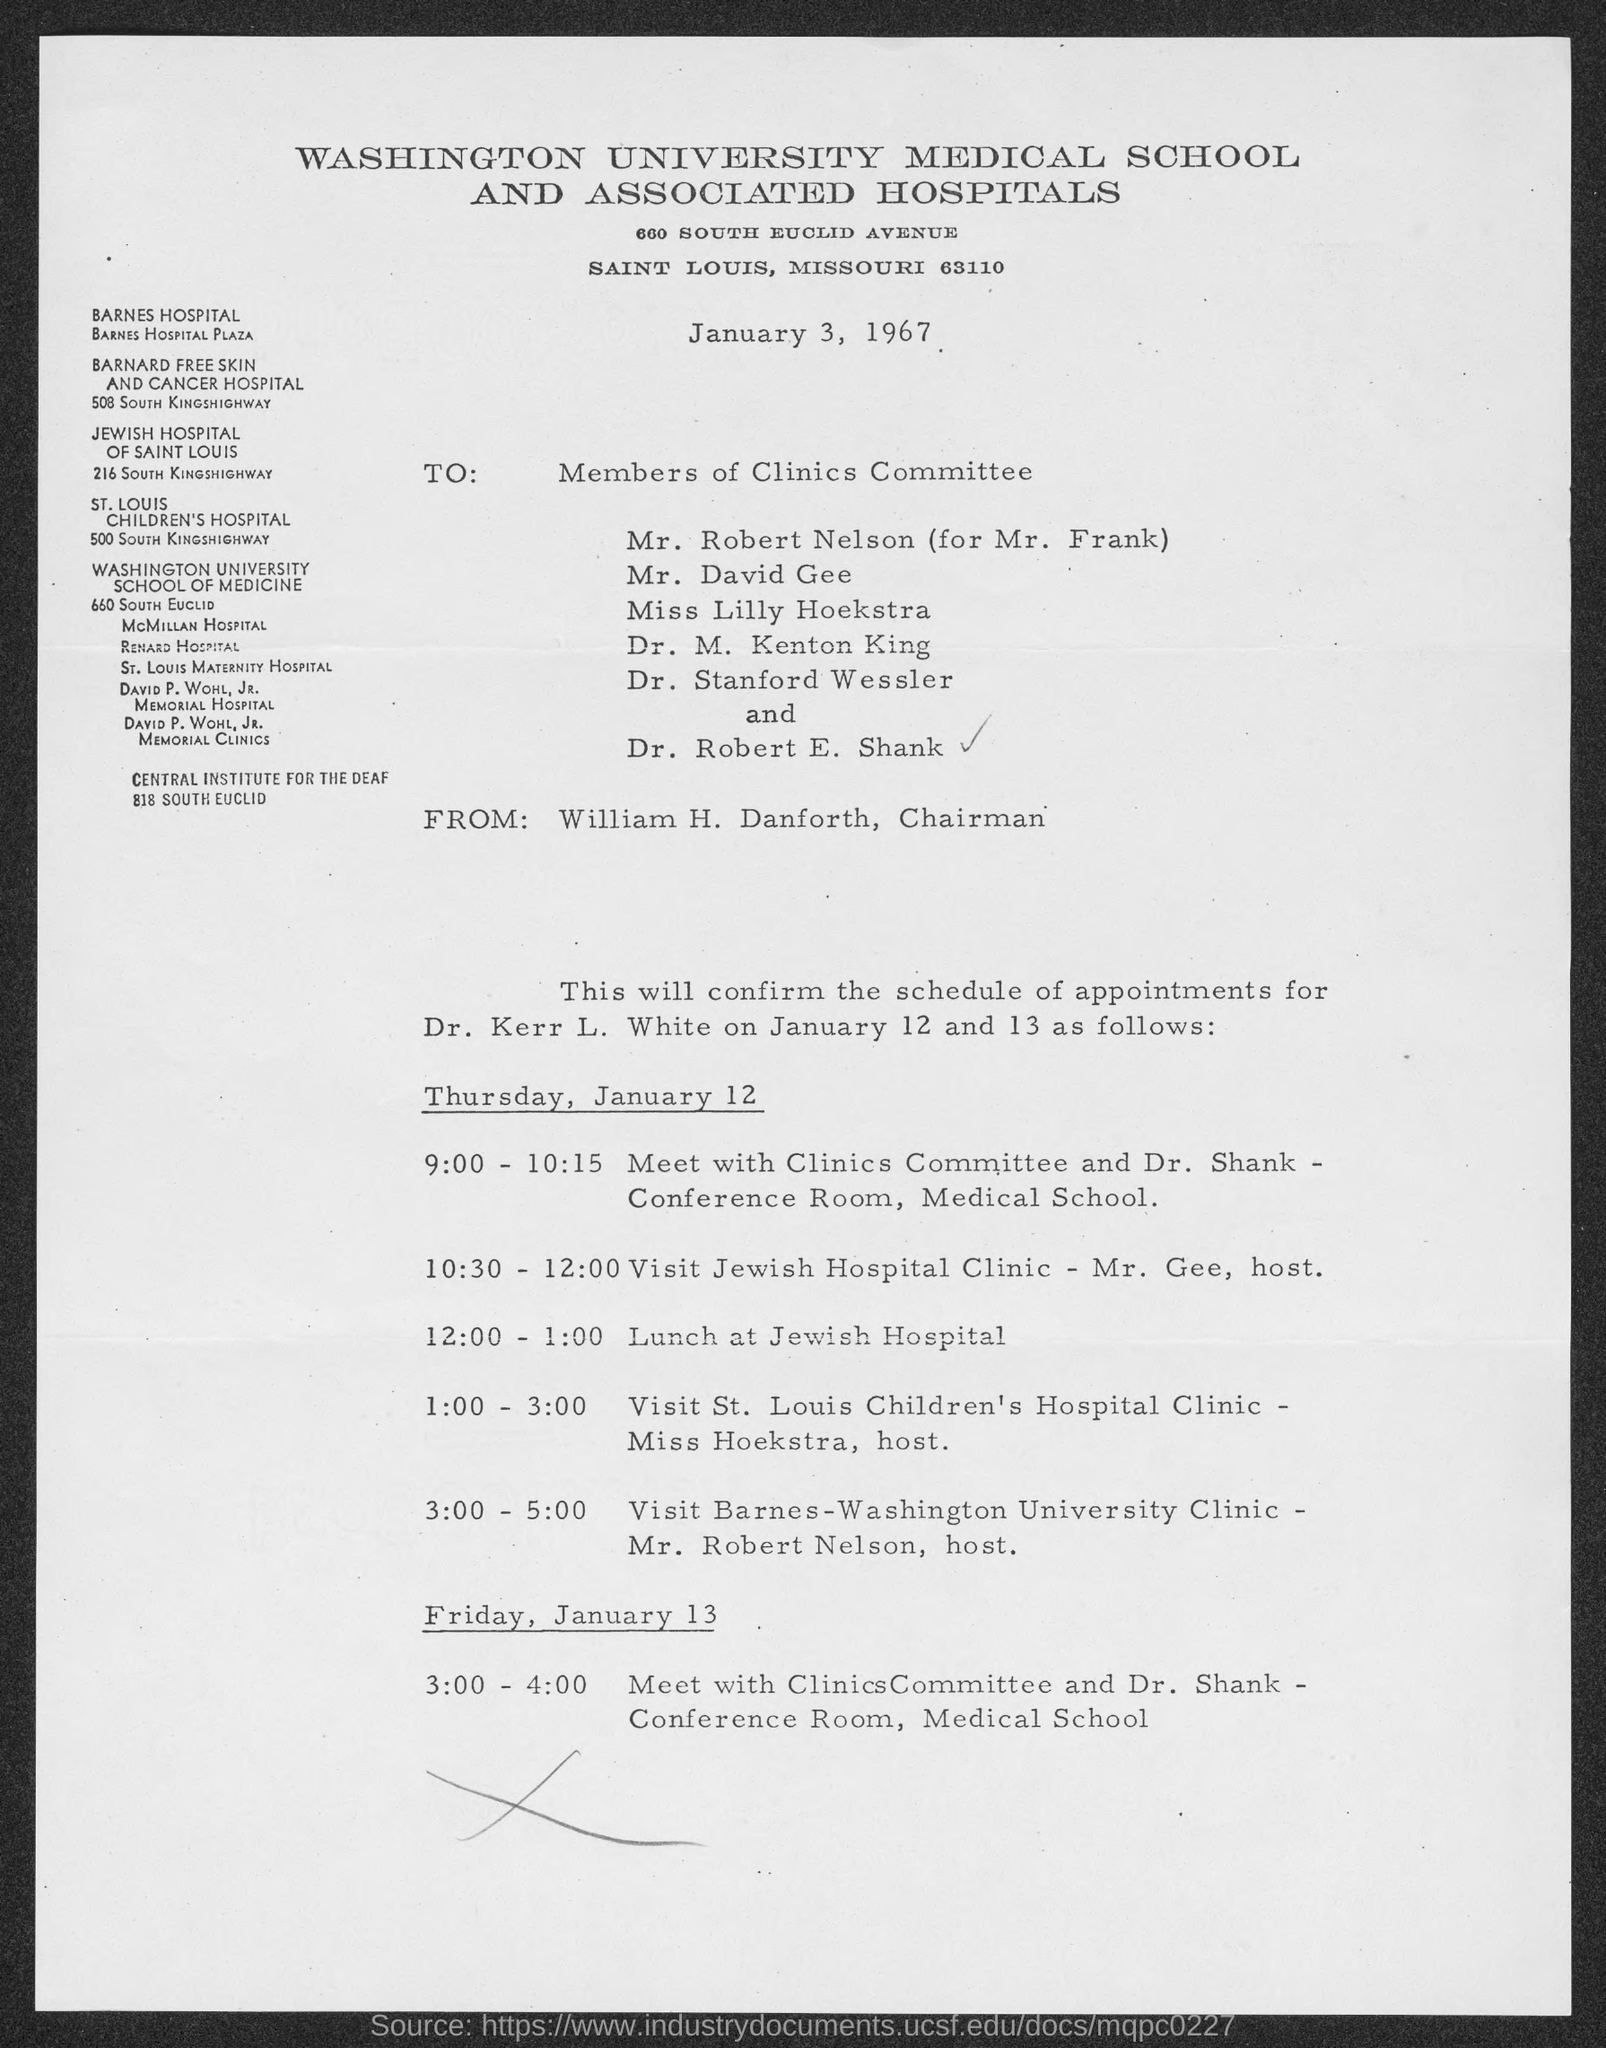When is the document dated?
Keep it short and to the point. January 3, 1967. From whom is the document?
Provide a succinct answer. William H. Danforth. For whom is the schedule of appointments?
Offer a very short reply. Dr. Kerr L. White. What is the appointment from 12:00 - 1:00?
Your response must be concise. Lunch at Jewish Hospital. 